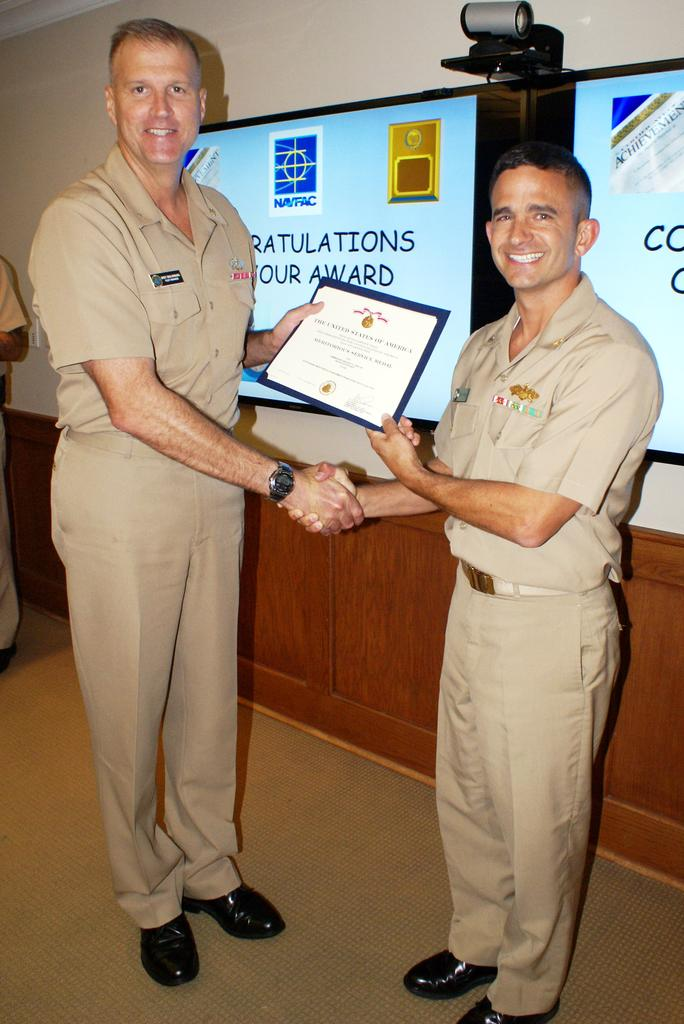How many persons are visible in the image? There are persons standing in the image. What is one of the persons holding? One of the persons is holding a certificate. What can be seen in the background of the image? There is a CCTV camera and an advertisement in the background of the image. What type of machine is responsible for the birth of the persons in the image? There is no machine or birth event depicted in the image; it simply shows persons standing and holding a certificate. 